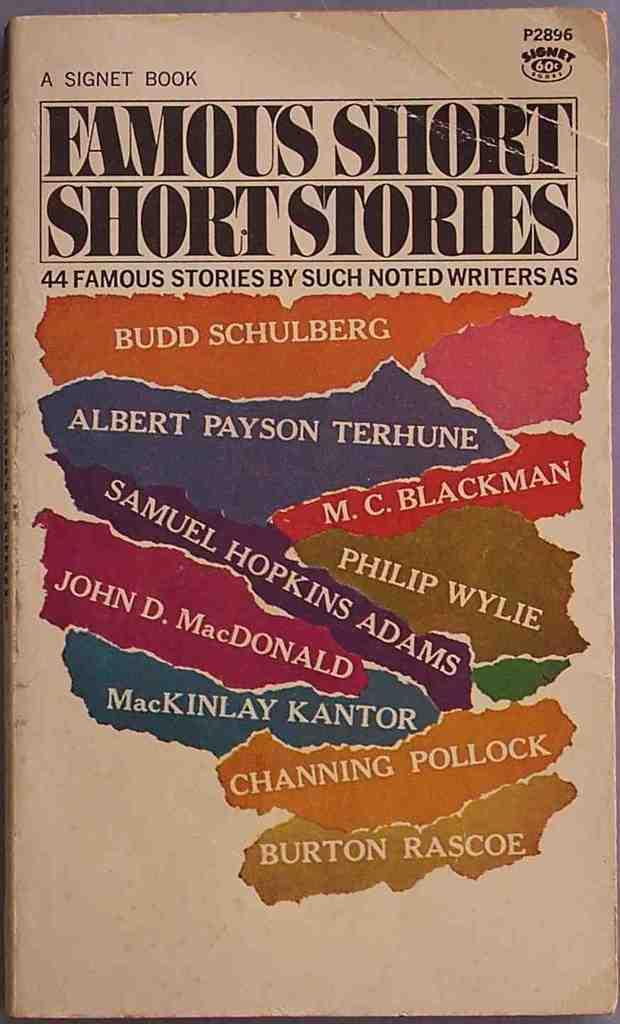<image>
Render a clear and concise summary of the photo. The front cover of a collection of short stories by well-known authors like Channing Pollock and Philip Wylie. 